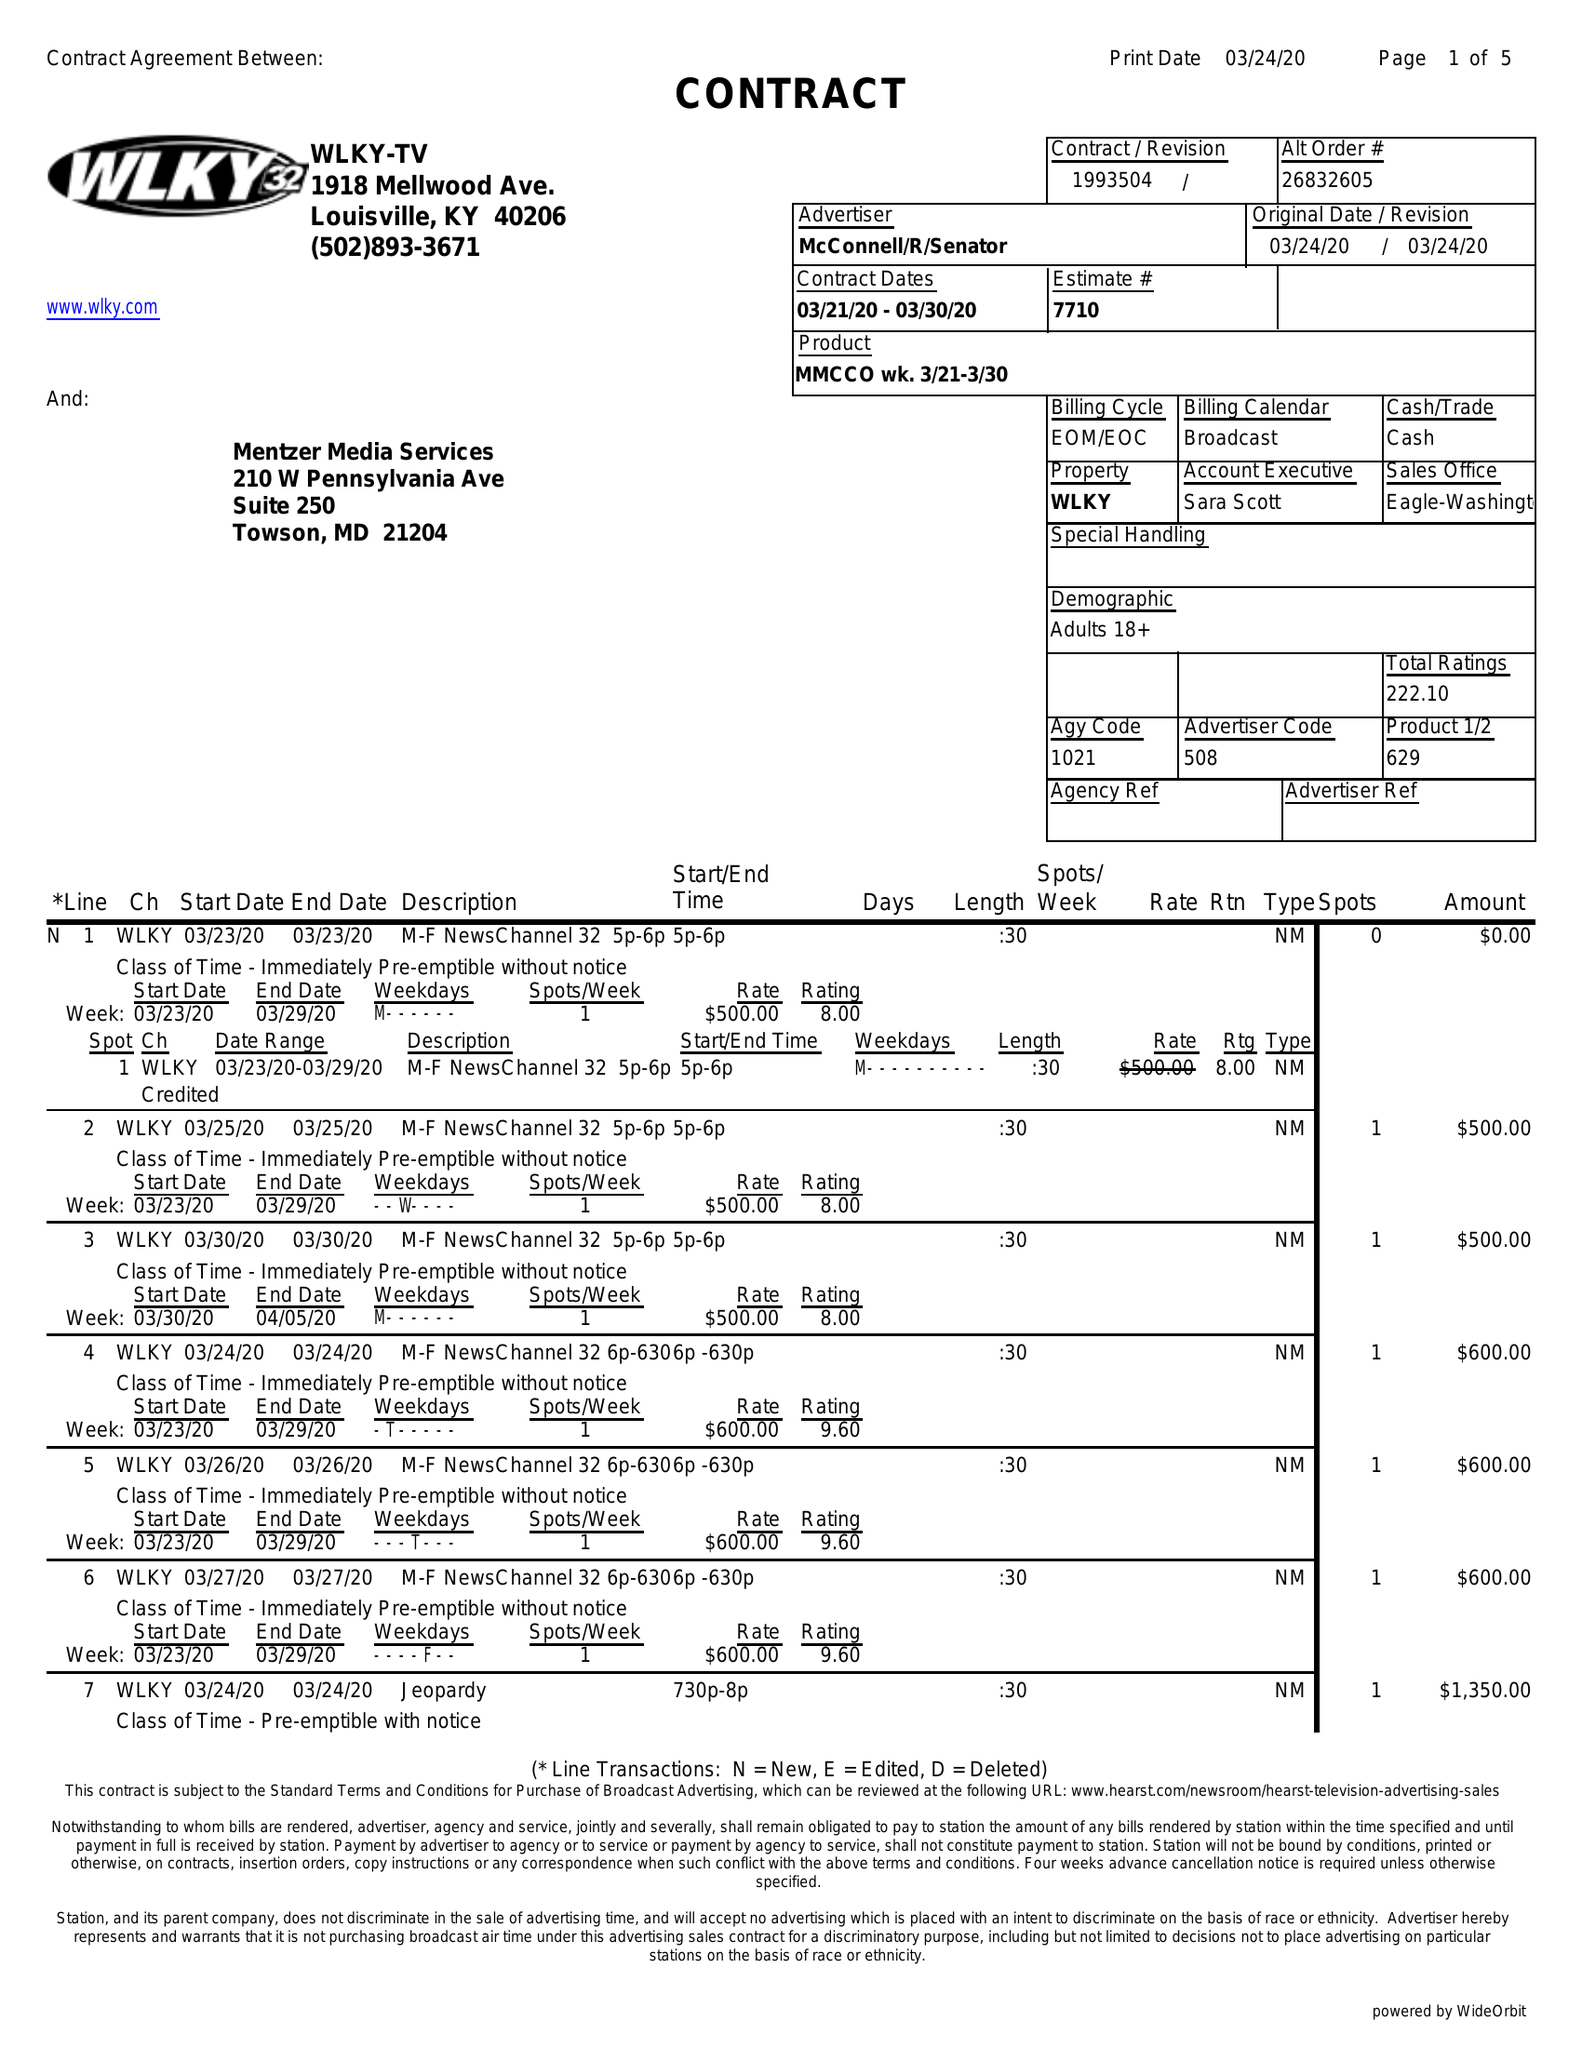What is the value for the flight_to?
Answer the question using a single word or phrase. 03/30/20 